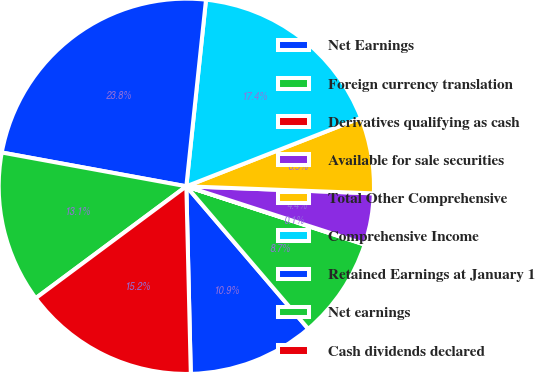Convert chart to OTSL. <chart><loc_0><loc_0><loc_500><loc_500><pie_chart><fcel>Net Earnings<fcel>Foreign currency translation<fcel>Derivatives qualifying as cash<fcel>Available for sale securities<fcel>Total Other Comprehensive<fcel>Comprehensive Income<fcel>Retained Earnings at January 1<fcel>Net earnings<fcel>Cash dividends declared<nl><fcel>10.88%<fcel>8.71%<fcel>0.05%<fcel>4.38%<fcel>6.55%<fcel>17.38%<fcel>23.79%<fcel>13.05%<fcel>15.21%<nl></chart> 